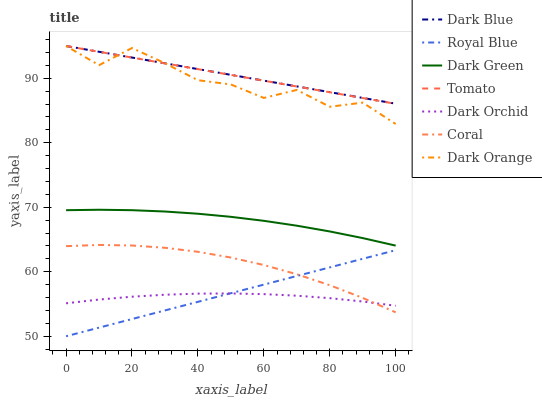Does Dark Orchid have the minimum area under the curve?
Answer yes or no. Yes. Does Dark Orange have the minimum area under the curve?
Answer yes or no. No. Does Dark Orange have the maximum area under the curve?
Answer yes or no. No. Is Dark Orange the roughest?
Answer yes or no. Yes. Is Dark Orange the smoothest?
Answer yes or no. No. Is Royal Blue the roughest?
Answer yes or no. No. Does Dark Orange have the lowest value?
Answer yes or no. No. Does Royal Blue have the highest value?
Answer yes or no. No. Is Dark Orchid less than Dark Blue?
Answer yes or no. Yes. Is Dark Green greater than Royal Blue?
Answer yes or no. Yes. Does Dark Orchid intersect Dark Blue?
Answer yes or no. No. 